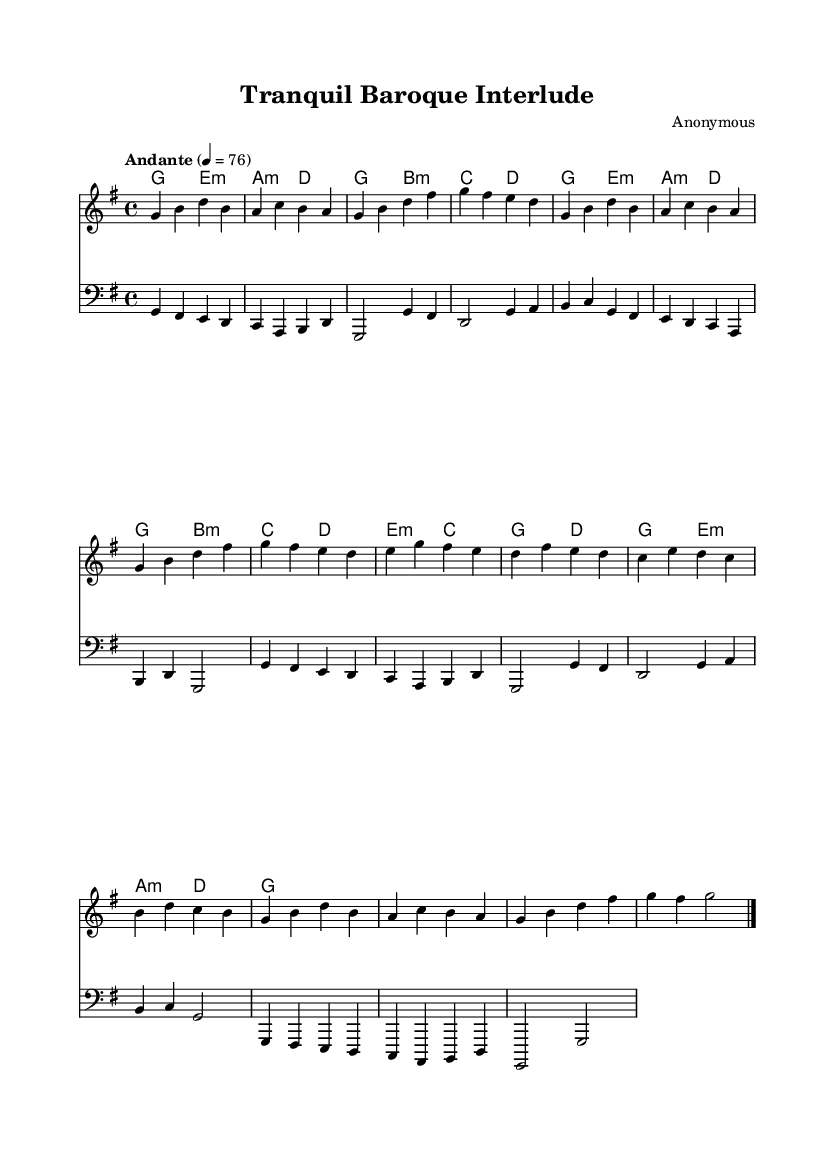What is the key signature of this music? The key signature is indicated at the beginning of the staff and shows one sharp. This means the pieces are in the key of G major.
Answer: G major What is the time signature of the piece? The time signature is found at the beginning of the staff, showing a "4 over 4," which indicates a common time meter.
Answer: 4/4 What is the tempo marking given for this piece? The tempo marking is written above the staff, which states "Andante" followed by 4 equals 76, indicating a moderate speed.
Answer: Andante How many sections does the piece contain? By analyzing the layout of the music, we see distinct sections labeled A, B, and A' which means there are three sections total.
Answer: Three What is the first note of the melody? The first note of the melody is the lowest note on the first bar, which is a G, indicating it starts on the tonic of the key.
Answer: G What type of harmonic progression is primarily used in this piece? The harmonic progression is identified by looking at the chord names marked in the chord staff section, which primarily showcase a diatonic progression typical in Baroque music.
Answer: Diatonic What is the structure of the B section? The B section is analyzed by observing the sequence of notes and chords. It consists of a contrasting tonal and melodic plan compared to the A section, highlighting different thematic material.
Answer: Contrasting 